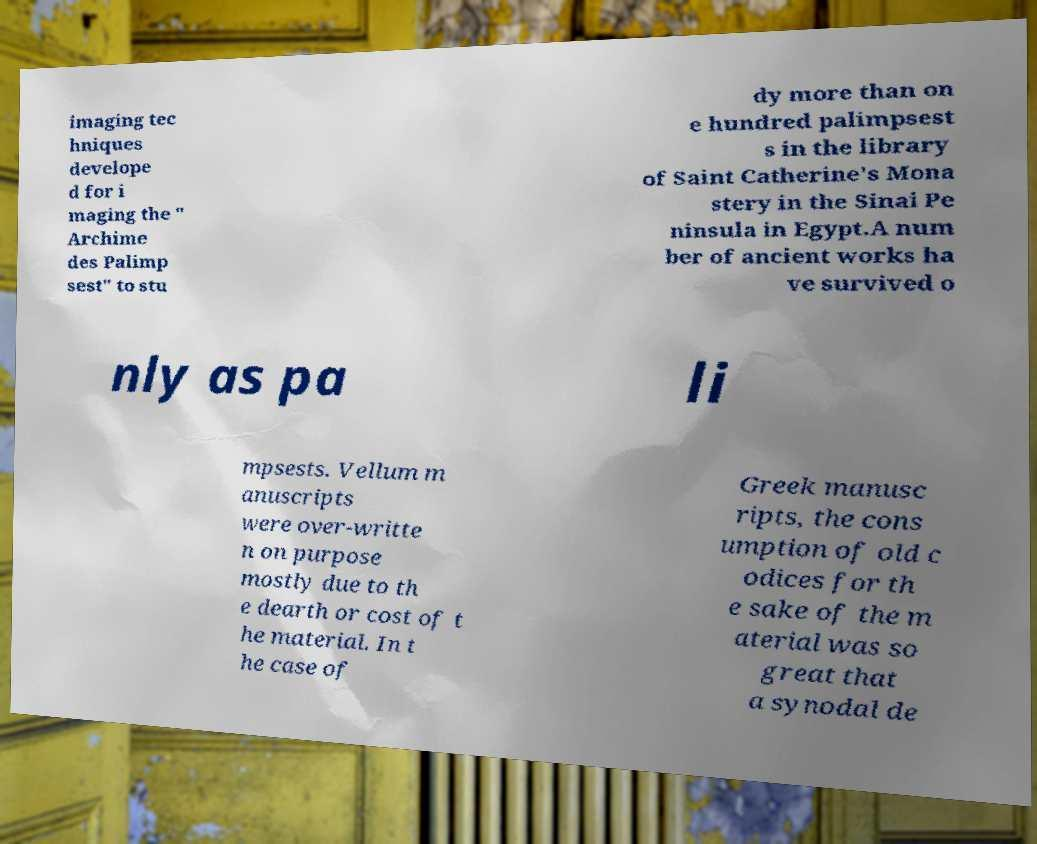There's text embedded in this image that I need extracted. Can you transcribe it verbatim? imaging tec hniques develope d for i maging the " Archime des Palimp sest" to stu dy more than on e hundred palimpsest s in the library of Saint Catherine's Mona stery in the Sinai Pe ninsula in Egypt.A num ber of ancient works ha ve survived o nly as pa li mpsests. Vellum m anuscripts were over-writte n on purpose mostly due to th e dearth or cost of t he material. In t he case of Greek manusc ripts, the cons umption of old c odices for th e sake of the m aterial was so great that a synodal de 